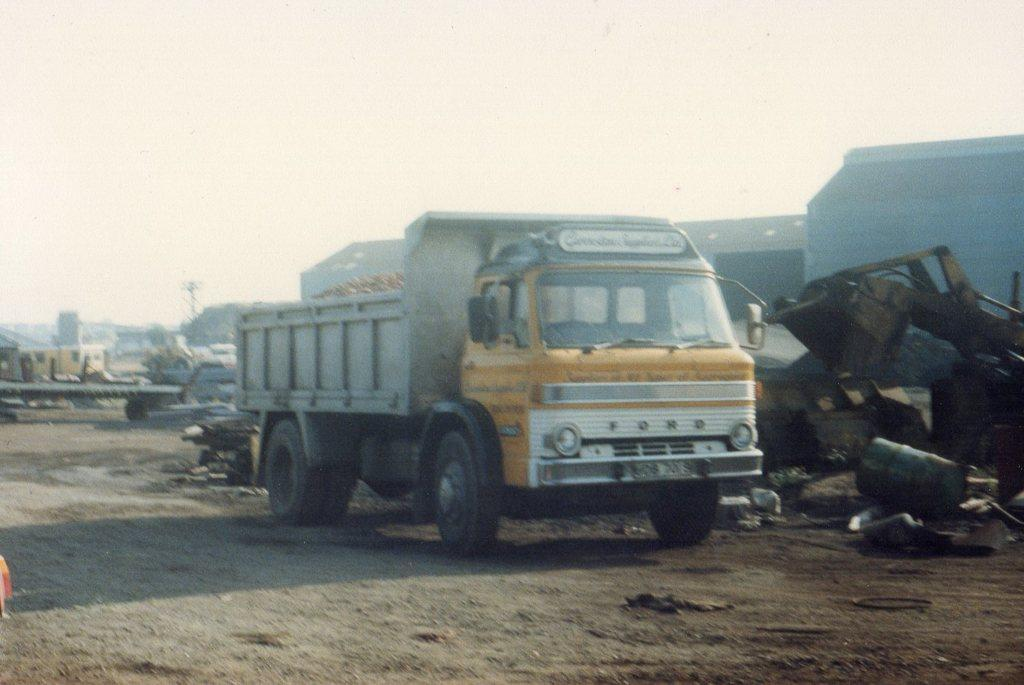What types of objects are present in the image? There are vehicles, trash, and a drum in the image. What type of structure can be seen in the image? There are walls in the image. What is visible in the background of the image? The sky is visible in the background of the image. How does the turkey contribute to the destruction in the image? There is no turkey present in the image, so it cannot contribute to any destruction. 